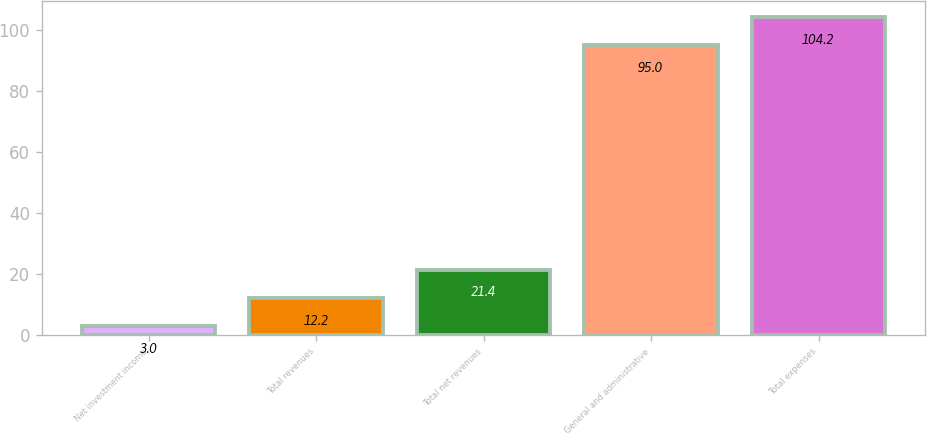<chart> <loc_0><loc_0><loc_500><loc_500><bar_chart><fcel>Net investment income<fcel>Total revenues<fcel>Total net revenues<fcel>General and administrative<fcel>Total expenses<nl><fcel>3<fcel>12.2<fcel>21.4<fcel>95<fcel>104.2<nl></chart> 